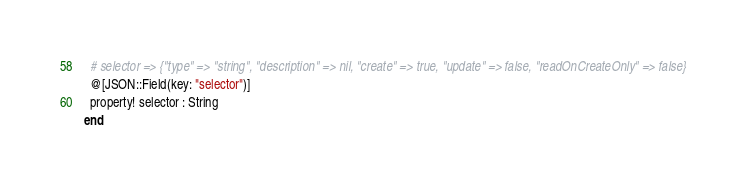Convert code to text. <code><loc_0><loc_0><loc_500><loc_500><_Crystal_>
  # selector => {"type" => "string", "description" => nil, "create" => true, "update" => false, "readOnCreateOnly" => false}
  @[JSON::Field(key: "selector")]
  property! selector : String
end
</code> 